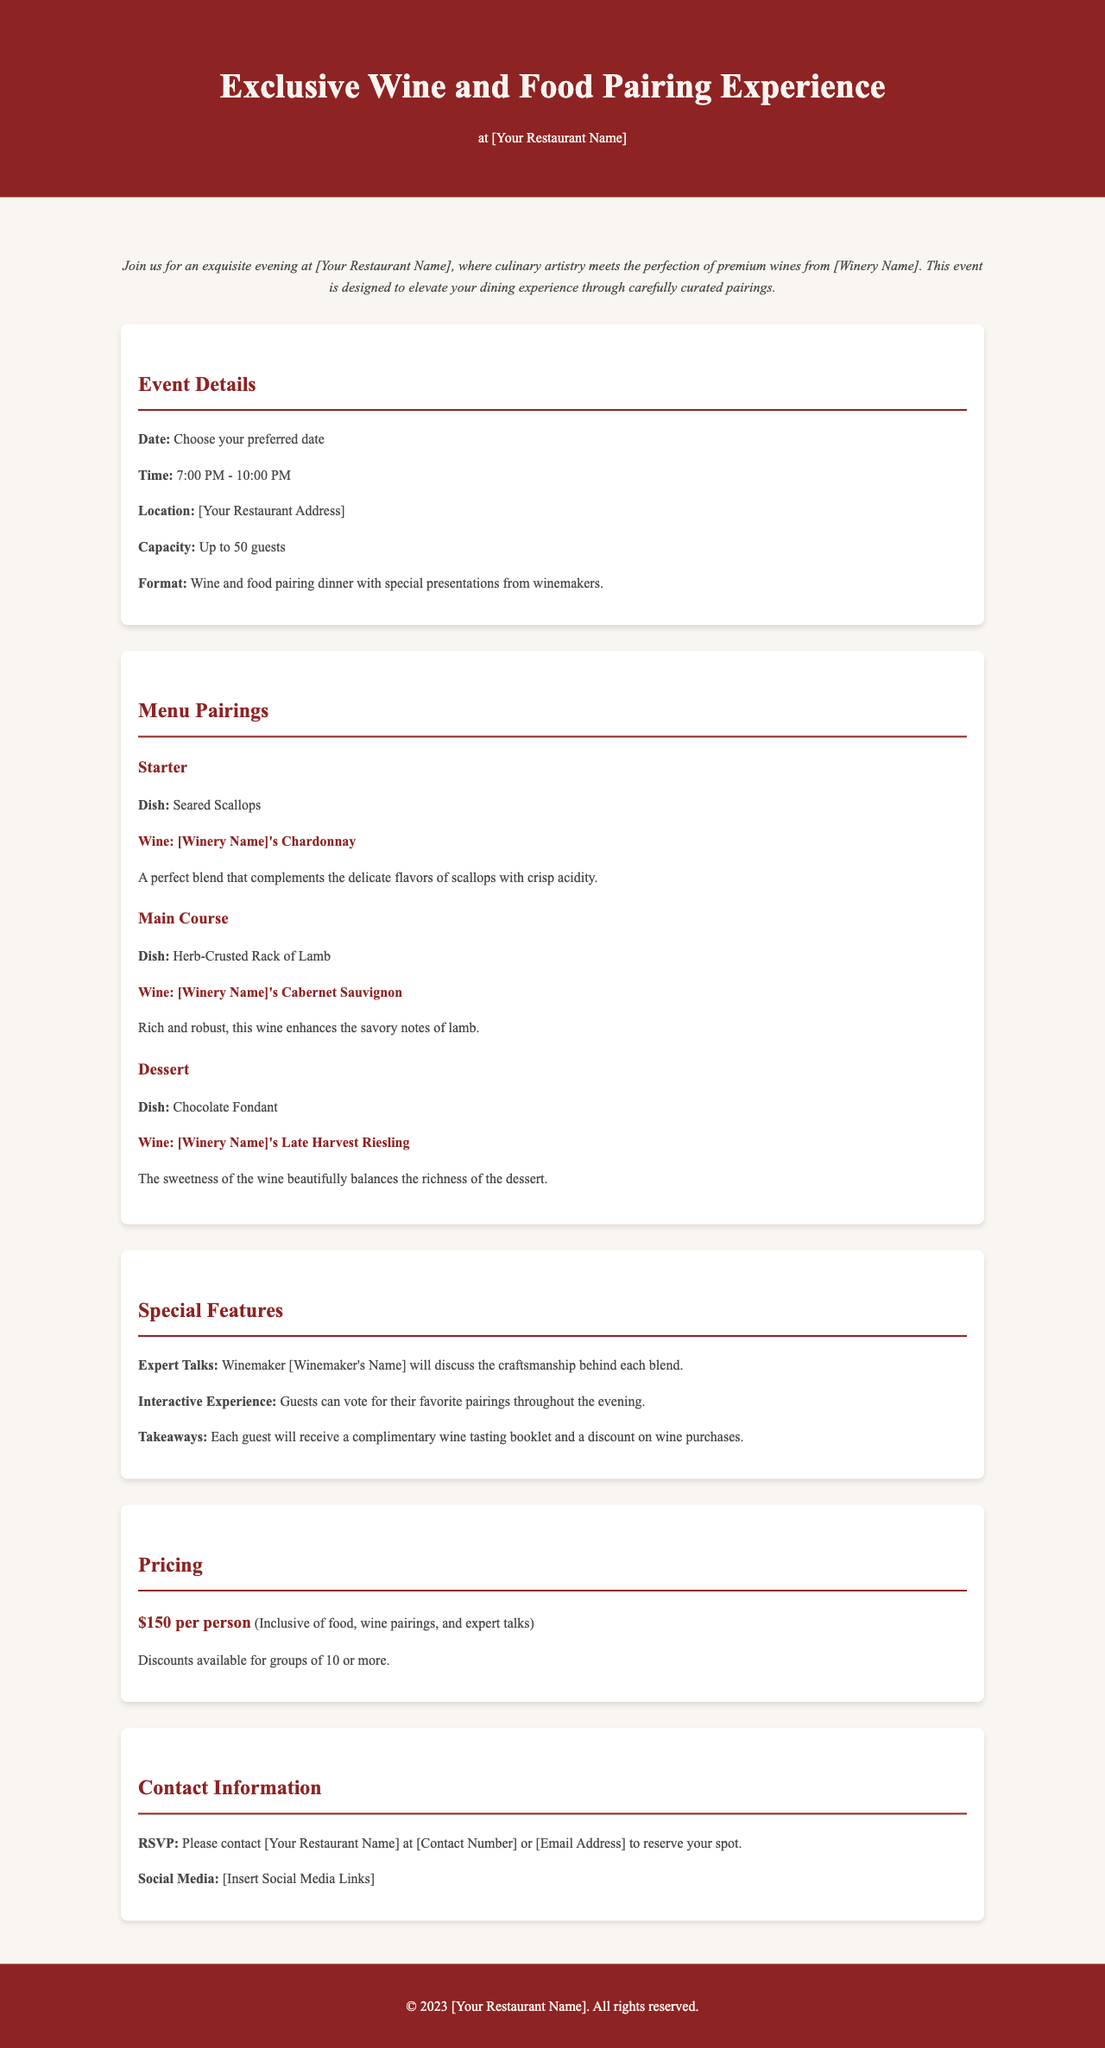What is the date of the event? The document states that attendees can choose their preferred date for the event.
Answer: Choose your preferred date What is the capacity of the event? The document specifies that the event can accommodate up to 50 guests.
Answer: Up to 50 guests What is the price per person for the event? The pricing section indicates that it costs $150 per person to attend the event.
Answer: $150 per person Which wine pairs with the dessert? The menu pairing for dessert shows that the Late Harvest Riesling from the winery is the pairing for the chocolate fondant.
Answer: [Winery Name]'s Late Harvest Riesling Who will be discussing the blends during the event? The special features section mentions that the winemaker will discuss the craftsmanship behind each blend.
Answer: Winemaker [Winemaker's Name] What type of experience is offered during the event? The document indicates that there will be an interactive experience where guests can vote for their favorite pairings.
Answer: Interactive Experience What do guests receive as takeaways? The special features section notes that guests will receive a complimentary wine tasting booklet and a discount on wine purchases.
Answer: Complimentary wine tasting booklet and discount on wine purchases 